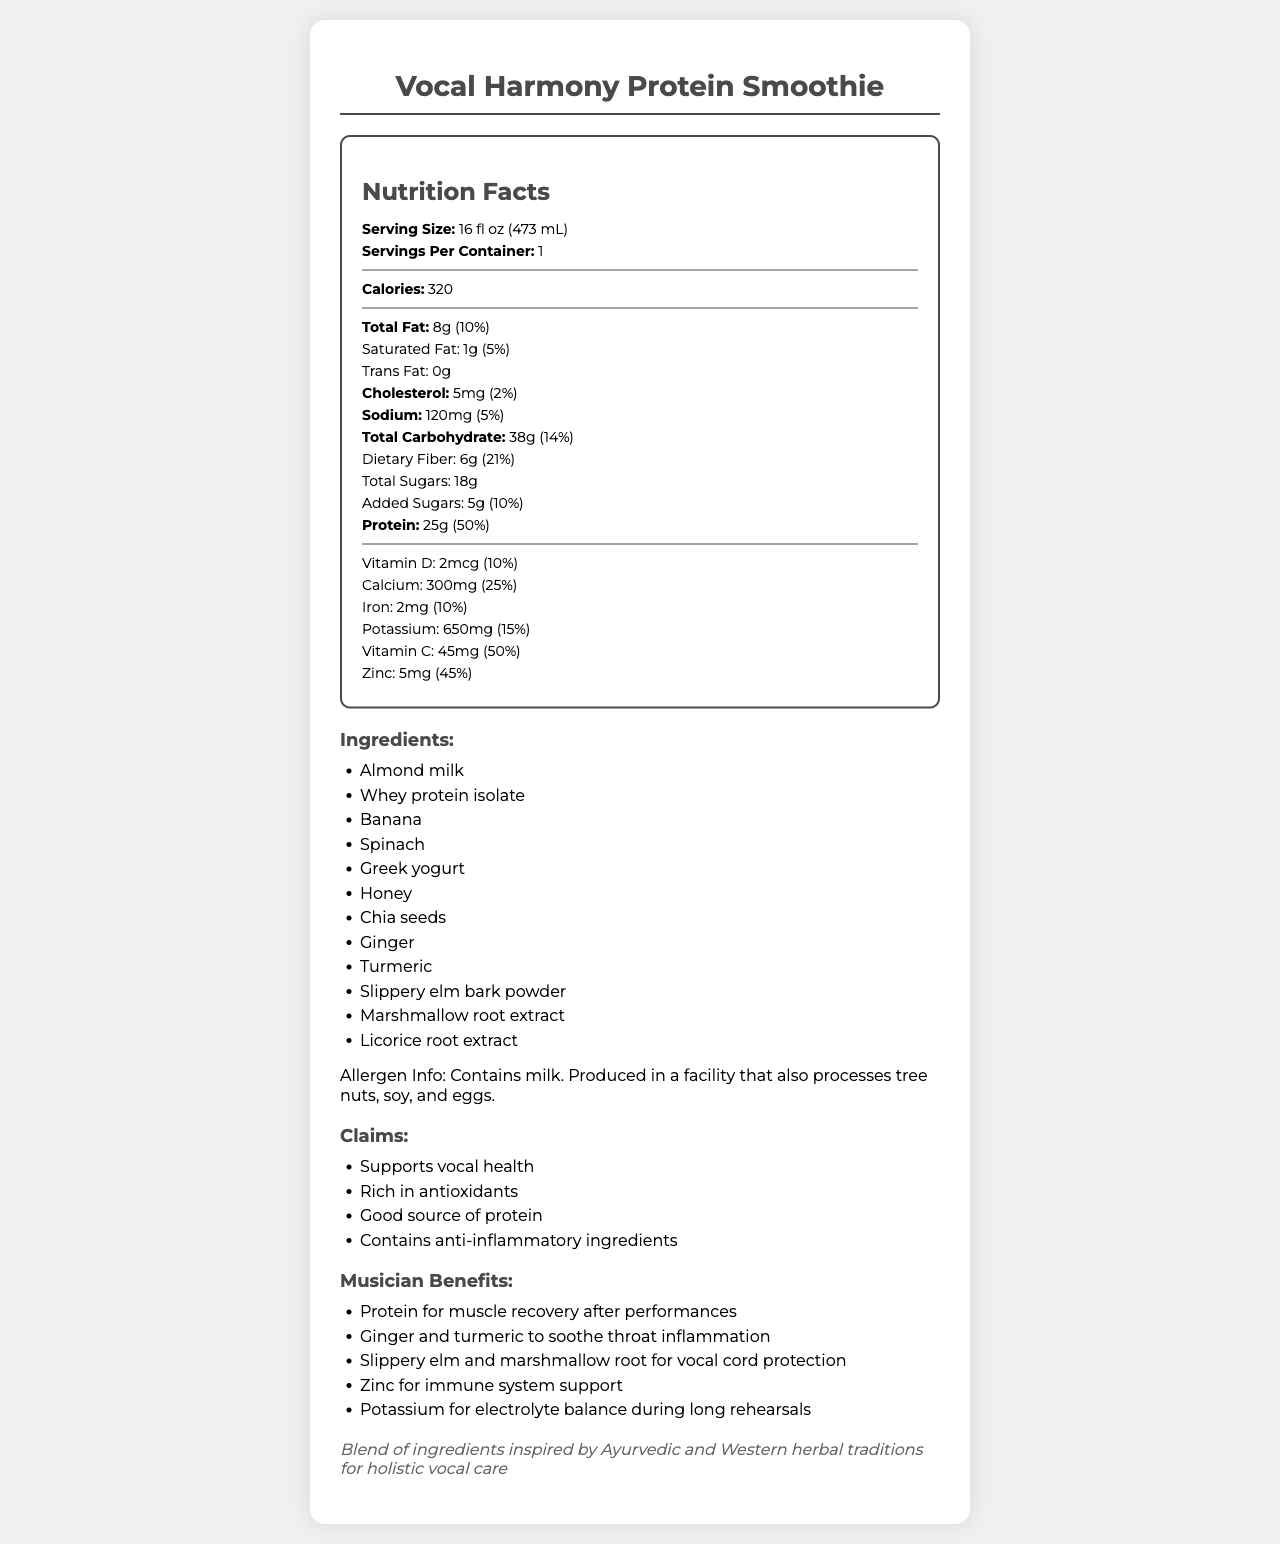what is the serving size of Vocal Harmony Protein Smoothie? The serving size is explicitly mentioned under the "Serving Size" section of the Nutrition Facts.
Answer: 16 fl oz (473 mL) how many servings are there per container? The document specifies that there is 1 serving per container under the "Servings Per Container" section.
Answer: 1 how much total fat does this smoothie contain? The total fat content is listed as 8 grams in the Nutrition Facts.
Answer: 8g what is the percentage daily value of dietary fiber in the smoothie? The daily value percentage of dietary fiber is listed as 21% in the Nutrition Facts.
Answer: 21% how much protein is in the smoothie? The amount of protein provided by the smoothie is listed as 25 grams in the Nutrition Facts.
Answer: 25g What are the anti-inflammatory ingredients in the Vocal Harmony Protein Smoothie? (Choose all that apply) A. Turmeric B. Ginger C. Licorice root extract D. Banana E. Marshmallow root extract The anti-inflammatory ingredients mentioned are Turmeric, Ginger, Licorice root extract, and Marshmallow root extract. Banana is not listed as an anti-inflammatory ingredient.
Answer: A, B, C, E which ingredient provides a significant source of zinc? A. Almond milk B. Whey protein isolate C. Chia seeds D. Spinach Chia seeds are a known source of zinc, which matches the substantial amount of zinc (5mg, 45% DV) listed in the nutrition content.
Answer: C does this product support vocal health? Under the "claims" section, it's stated that the product "supports vocal health."
Answer: Yes describe the allergen information of the Vocal Harmony Protein Smoothie. The allergen information is clearly listed under the "Allergen Info" section.
Answer: Contains milk. Produced in a facility that also processes tree nuts, soy, and eggs. what is the main idea of the document? The document provides detailed nutritional information, ingredient list, health claims, musician-specific benefits, and cultural inspiration for the product.
Answer: A comprehensive breakdown of the nutritional information, ingredients, and musician-specific health benefits of the Vocal Harmony Protein Smoothie, specially designed to support vocal health and sourced from Ayurvedic and Western herbal traditions. what color is the packaging of the Vocal Harmony Protein Smoothie? The document does not provide any visual or textual information about the color or design of the product packaging.
Answer: Not enough information 